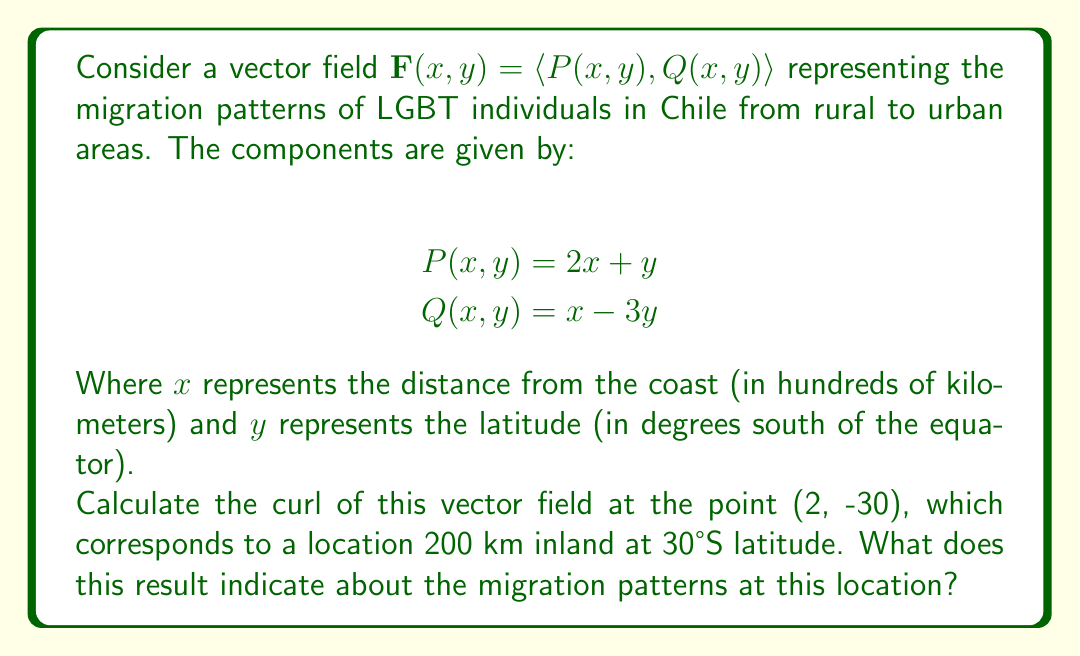Can you solve this math problem? To solve this problem, we'll follow these steps:

1) The curl of a two-dimensional vector field $\mathbf{F}(x,y) = \langle P(x,y), Q(x,y) \rangle$ is given by:

   $\text{curl } \mathbf{F} = \frac{\partial Q}{\partial x} - \frac{\partial P}{\partial y}$

2) First, let's calculate the partial derivatives:

   $\frac{\partial Q}{\partial x} = \frac{\partial}{\partial x}(x - 3y) = 1$

   $\frac{\partial P}{\partial y} = \frac{\partial}{\partial y}(2x + y) = 1$

3) Now, we can calculate the curl:

   $\text{curl } \mathbf{F} = \frac{\partial Q}{\partial x} - \frac{\partial P}{\partial y} = 1 - 1 = 0$

4) This result is constant for all points in the field, including (2, -30).

5) Interpretation: The curl of a vector field measures its tendency to rotate around a point. A curl of zero indicates that there is no rotational component to the migration patterns at this location (or any location in this field). This means that the LGBT population is moving in a straight line path towards urban areas, without circling or spiraling.

In the context of LGBT migration in Chile, this could suggest that the movement from rural to urban areas is direct, possibly driven by factors such as seeking more accepting communities or better economic opportunities in cities.
Answer: The curl of the vector field at (2, -30) is 0. This indicates that there is no rotational component to the LGBT migration patterns at this location, suggesting a direct movement from rural to urban areas without circling or spiraling. 